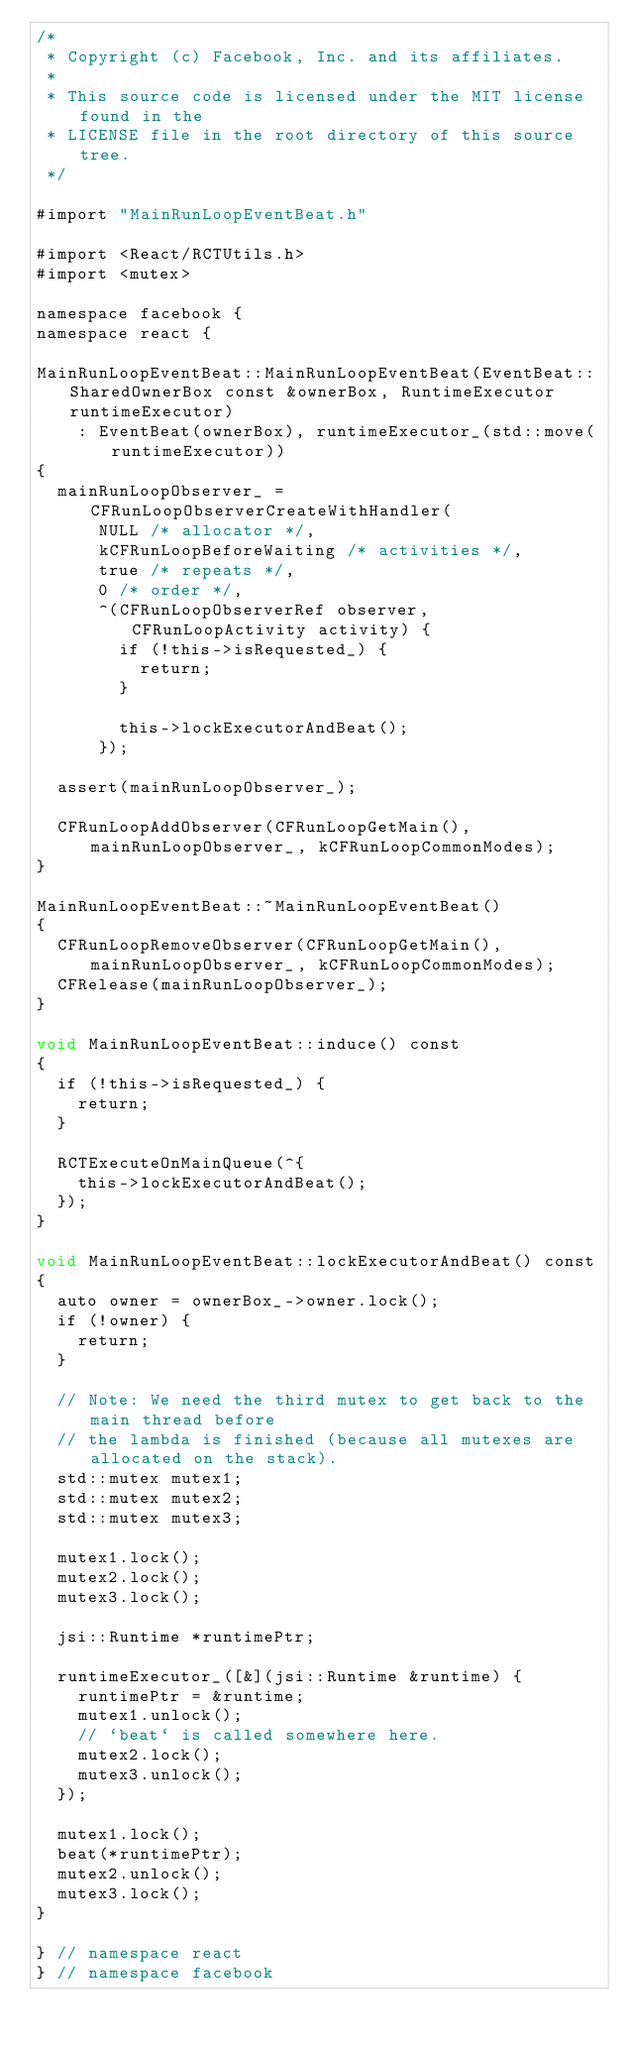Convert code to text. <code><loc_0><loc_0><loc_500><loc_500><_ObjectiveC_>/*
 * Copyright (c) Facebook, Inc. and its affiliates.
 *
 * This source code is licensed under the MIT license found in the
 * LICENSE file in the root directory of this source tree.
 */

#import "MainRunLoopEventBeat.h"

#import <React/RCTUtils.h>
#import <mutex>

namespace facebook {
namespace react {

MainRunLoopEventBeat::MainRunLoopEventBeat(EventBeat::SharedOwnerBox const &ownerBox, RuntimeExecutor runtimeExecutor)
    : EventBeat(ownerBox), runtimeExecutor_(std::move(runtimeExecutor))
{
  mainRunLoopObserver_ = CFRunLoopObserverCreateWithHandler(
      NULL /* allocator */,
      kCFRunLoopBeforeWaiting /* activities */,
      true /* repeats */,
      0 /* order */,
      ^(CFRunLoopObserverRef observer, CFRunLoopActivity activity) {
        if (!this->isRequested_) {
          return;
        }

        this->lockExecutorAndBeat();
      });

  assert(mainRunLoopObserver_);

  CFRunLoopAddObserver(CFRunLoopGetMain(), mainRunLoopObserver_, kCFRunLoopCommonModes);
}

MainRunLoopEventBeat::~MainRunLoopEventBeat()
{
  CFRunLoopRemoveObserver(CFRunLoopGetMain(), mainRunLoopObserver_, kCFRunLoopCommonModes);
  CFRelease(mainRunLoopObserver_);
}

void MainRunLoopEventBeat::induce() const
{
  if (!this->isRequested_) {
    return;
  }

  RCTExecuteOnMainQueue(^{
    this->lockExecutorAndBeat();
  });
}

void MainRunLoopEventBeat::lockExecutorAndBeat() const
{
  auto owner = ownerBox_->owner.lock();
  if (!owner) {
    return;
  }

  // Note: We need the third mutex to get back to the main thread before
  // the lambda is finished (because all mutexes are allocated on the stack).
  std::mutex mutex1;
  std::mutex mutex2;
  std::mutex mutex3;

  mutex1.lock();
  mutex2.lock();
  mutex3.lock();

  jsi::Runtime *runtimePtr;

  runtimeExecutor_([&](jsi::Runtime &runtime) {
    runtimePtr = &runtime;
    mutex1.unlock();
    // `beat` is called somewhere here.
    mutex2.lock();
    mutex3.unlock();
  });

  mutex1.lock();
  beat(*runtimePtr);
  mutex2.unlock();
  mutex3.lock();
}

} // namespace react
} // namespace facebook
</code> 